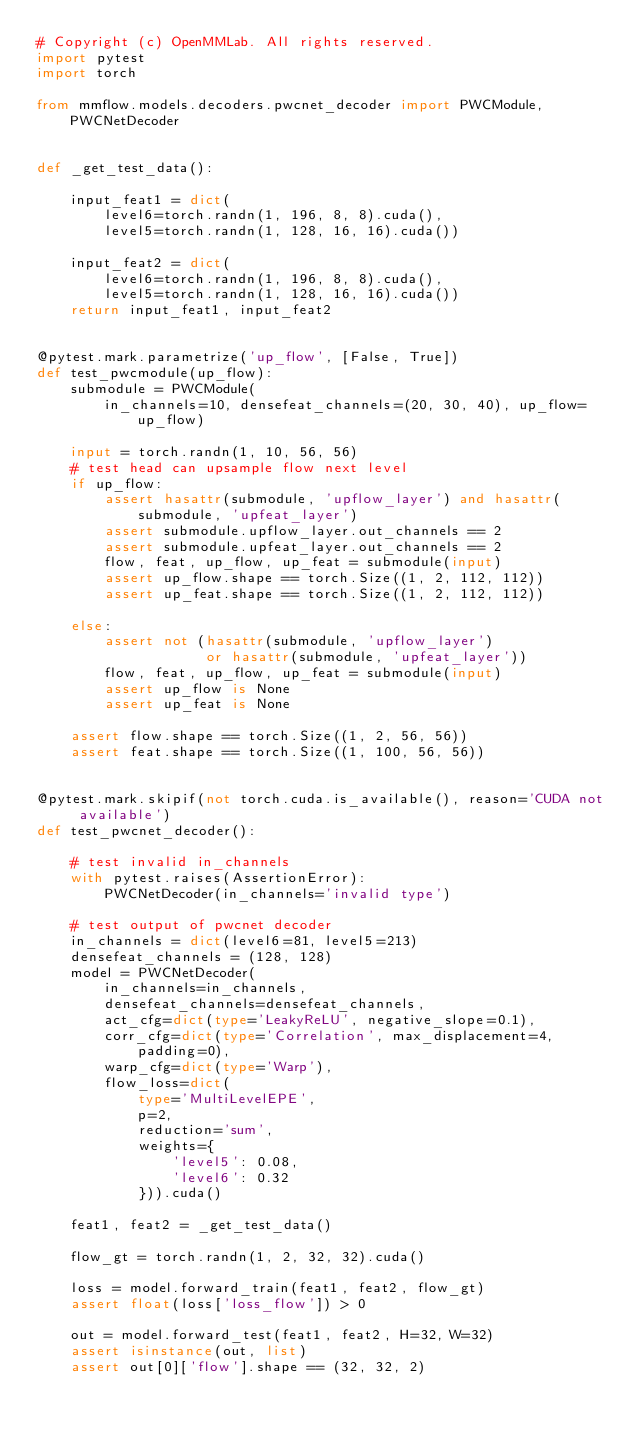Convert code to text. <code><loc_0><loc_0><loc_500><loc_500><_Python_># Copyright (c) OpenMMLab. All rights reserved.
import pytest
import torch

from mmflow.models.decoders.pwcnet_decoder import PWCModule, PWCNetDecoder


def _get_test_data():

    input_feat1 = dict(
        level6=torch.randn(1, 196, 8, 8).cuda(),
        level5=torch.randn(1, 128, 16, 16).cuda())

    input_feat2 = dict(
        level6=torch.randn(1, 196, 8, 8).cuda(),
        level5=torch.randn(1, 128, 16, 16).cuda())
    return input_feat1, input_feat2


@pytest.mark.parametrize('up_flow', [False, True])
def test_pwcmodule(up_flow):
    submodule = PWCModule(
        in_channels=10, densefeat_channels=(20, 30, 40), up_flow=up_flow)

    input = torch.randn(1, 10, 56, 56)
    # test head can upsample flow next level
    if up_flow:
        assert hasattr(submodule, 'upflow_layer') and hasattr(
            submodule, 'upfeat_layer')
        assert submodule.upflow_layer.out_channels == 2
        assert submodule.upfeat_layer.out_channels == 2
        flow, feat, up_flow, up_feat = submodule(input)
        assert up_flow.shape == torch.Size((1, 2, 112, 112))
        assert up_feat.shape == torch.Size((1, 2, 112, 112))

    else:
        assert not (hasattr(submodule, 'upflow_layer')
                    or hasattr(submodule, 'upfeat_layer'))
        flow, feat, up_flow, up_feat = submodule(input)
        assert up_flow is None
        assert up_feat is None

    assert flow.shape == torch.Size((1, 2, 56, 56))
    assert feat.shape == torch.Size((1, 100, 56, 56))


@pytest.mark.skipif(not torch.cuda.is_available(), reason='CUDA not available')
def test_pwcnet_decoder():

    # test invalid in_channels
    with pytest.raises(AssertionError):
        PWCNetDecoder(in_channels='invalid type')

    # test output of pwcnet decoder
    in_channels = dict(level6=81, level5=213)
    densefeat_channels = (128, 128)
    model = PWCNetDecoder(
        in_channels=in_channels,
        densefeat_channels=densefeat_channels,
        act_cfg=dict(type='LeakyReLU', negative_slope=0.1),
        corr_cfg=dict(type='Correlation', max_displacement=4, padding=0),
        warp_cfg=dict(type='Warp'),
        flow_loss=dict(
            type='MultiLevelEPE',
            p=2,
            reduction='sum',
            weights={
                'level5': 0.08,
                'level6': 0.32
            })).cuda()

    feat1, feat2 = _get_test_data()

    flow_gt = torch.randn(1, 2, 32, 32).cuda()

    loss = model.forward_train(feat1, feat2, flow_gt)
    assert float(loss['loss_flow']) > 0

    out = model.forward_test(feat1, feat2, H=32, W=32)
    assert isinstance(out, list)
    assert out[0]['flow'].shape == (32, 32, 2)
</code> 